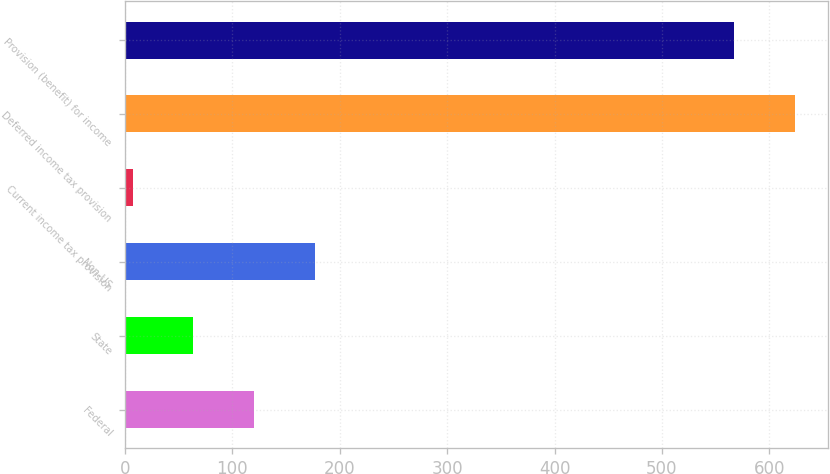<chart> <loc_0><loc_0><loc_500><loc_500><bar_chart><fcel>Federal<fcel>State<fcel>Non-US<fcel>Current income tax provision<fcel>Deferred income tax provision<fcel>Provision (benefit) for income<nl><fcel>120.4<fcel>63.7<fcel>177.1<fcel>7<fcel>623.7<fcel>567<nl></chart> 